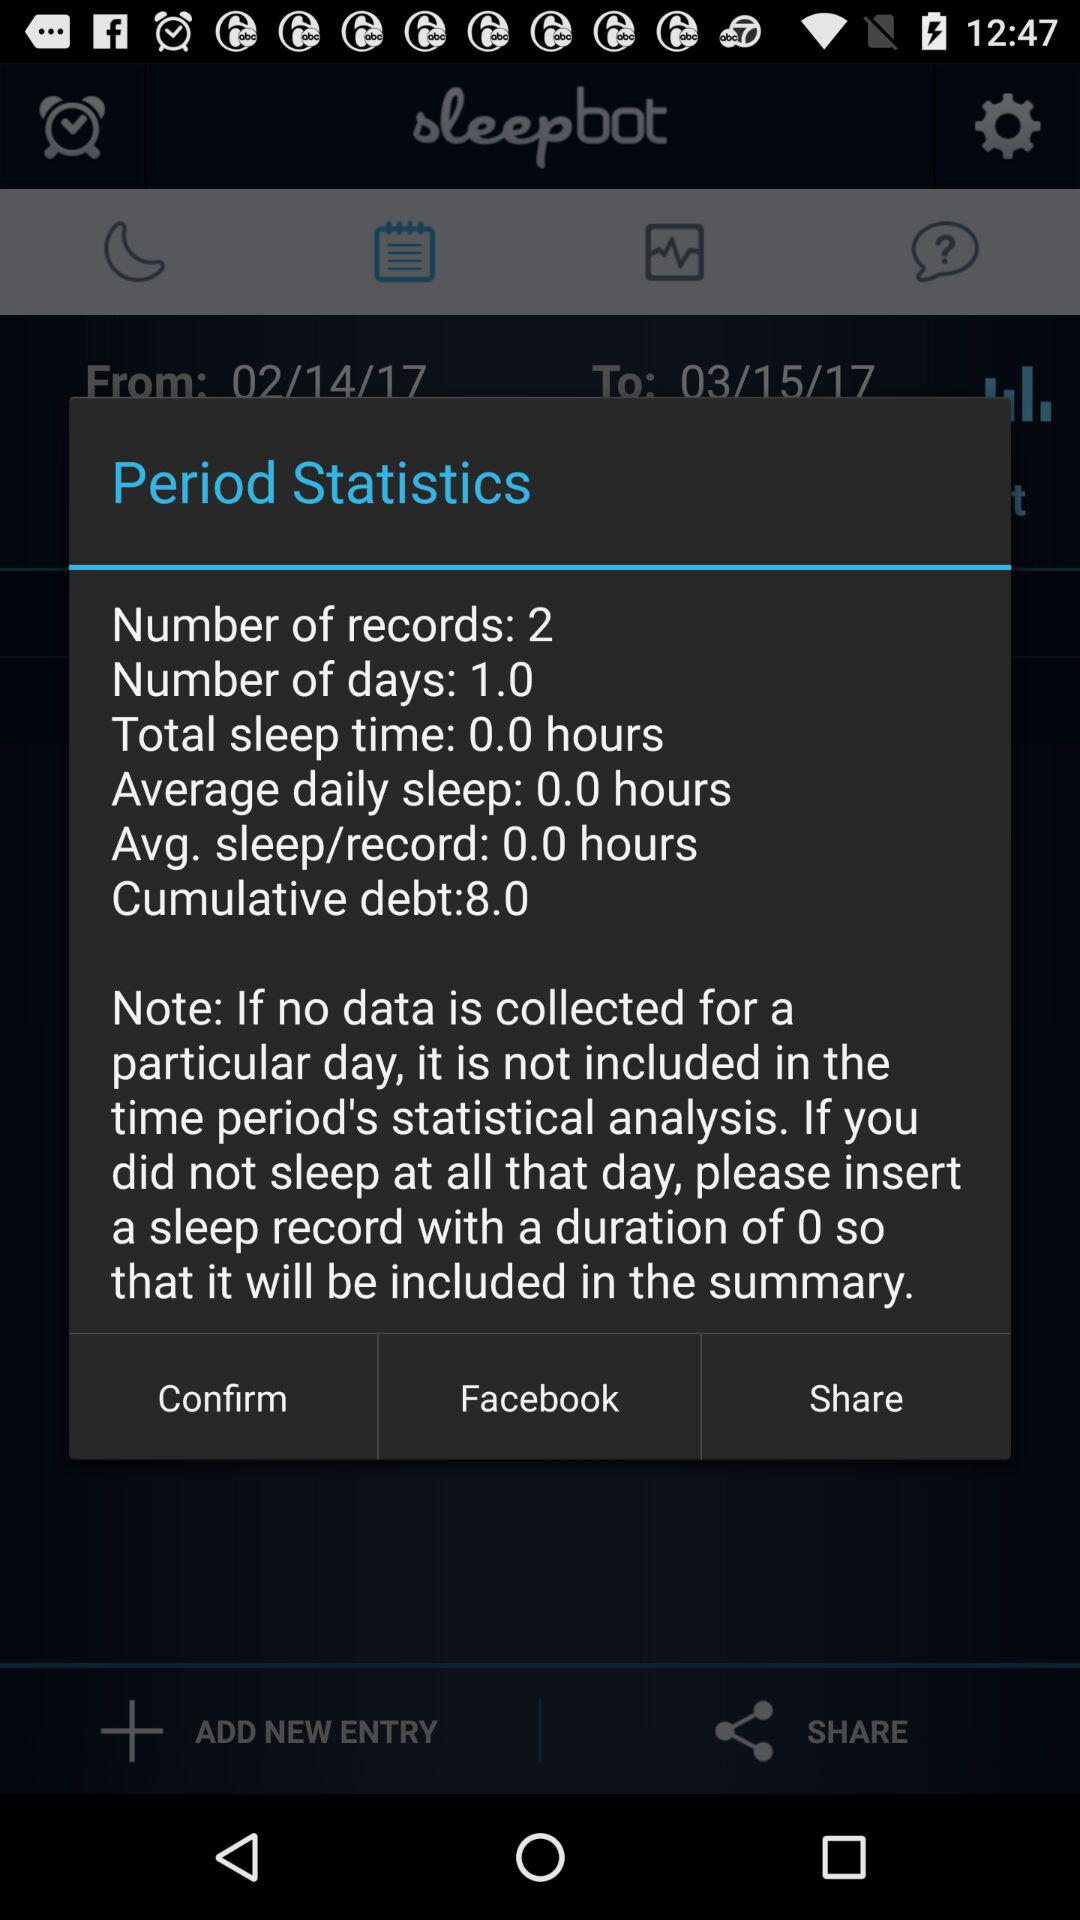What is the number of days? The number of days is 1. 